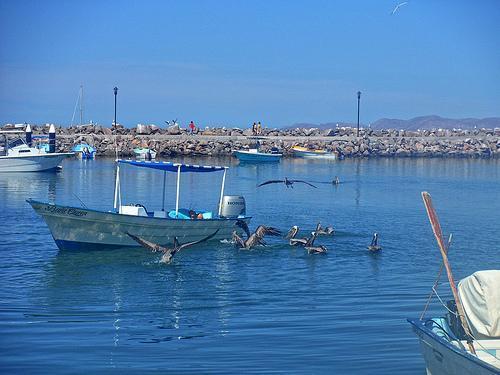How many birds are not touching the water in this image?
Give a very brief answer. 1. How many birds are in the air?
Give a very brief answer. 1. 